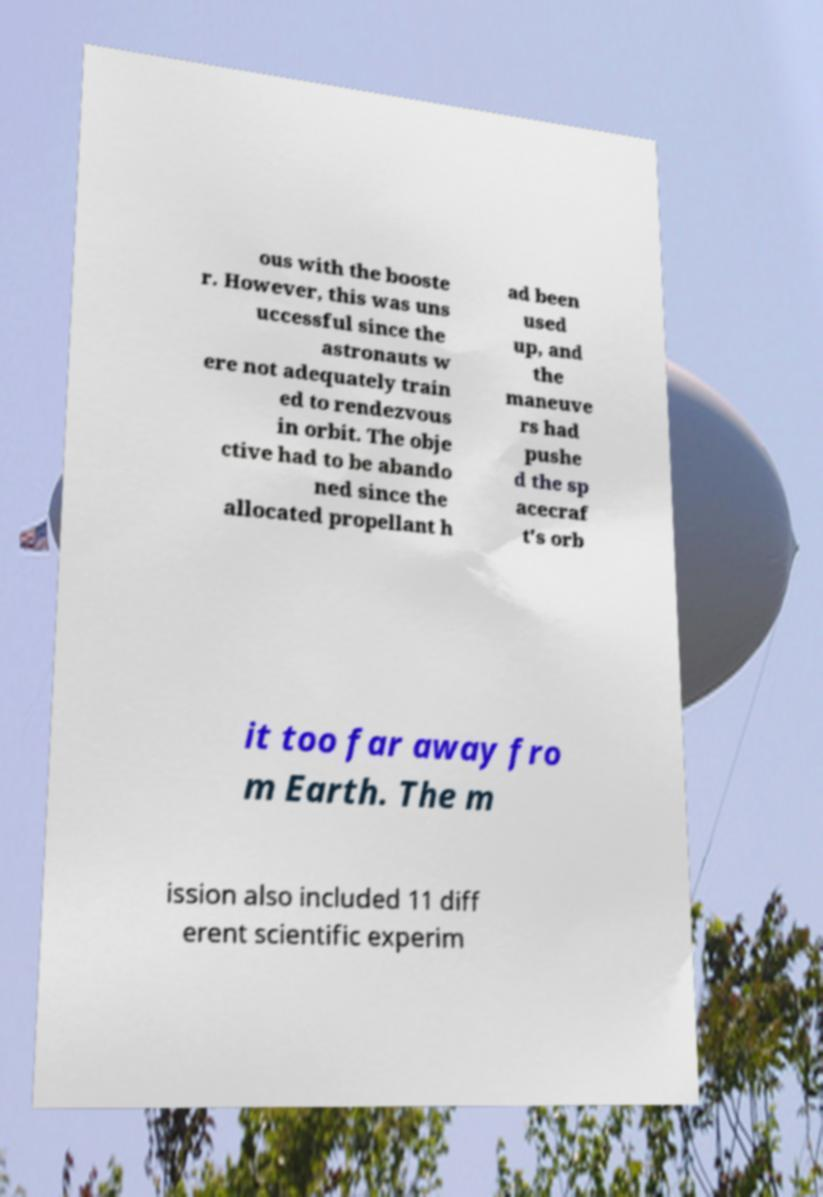What messages or text are displayed in this image? I need them in a readable, typed format. ous with the booste r. However, this was uns uccessful since the astronauts w ere not adequately train ed to rendezvous in orbit. The obje ctive had to be abando ned since the allocated propellant h ad been used up, and the maneuve rs had pushe d the sp acecraf t's orb it too far away fro m Earth. The m ission also included 11 diff erent scientific experim 